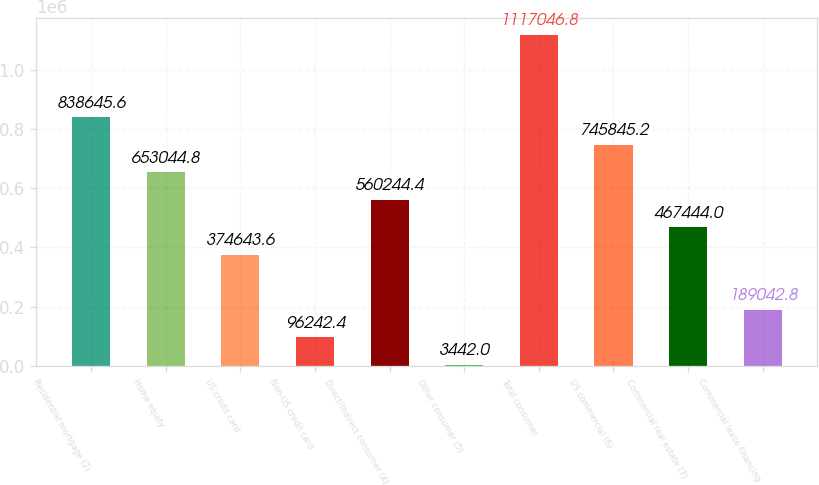Convert chart. <chart><loc_0><loc_0><loc_500><loc_500><bar_chart><fcel>Residential mortgage (2)<fcel>Home equity<fcel>US credit card<fcel>Non-US credit card<fcel>Direct/Indirect consumer (4)<fcel>Other consumer (5)<fcel>Total consumer<fcel>US commercial (6)<fcel>Commercial real estate (7)<fcel>Commercial lease financing<nl><fcel>838646<fcel>653045<fcel>374644<fcel>96242.4<fcel>560244<fcel>3442<fcel>1.11705e+06<fcel>745845<fcel>467444<fcel>189043<nl></chart> 